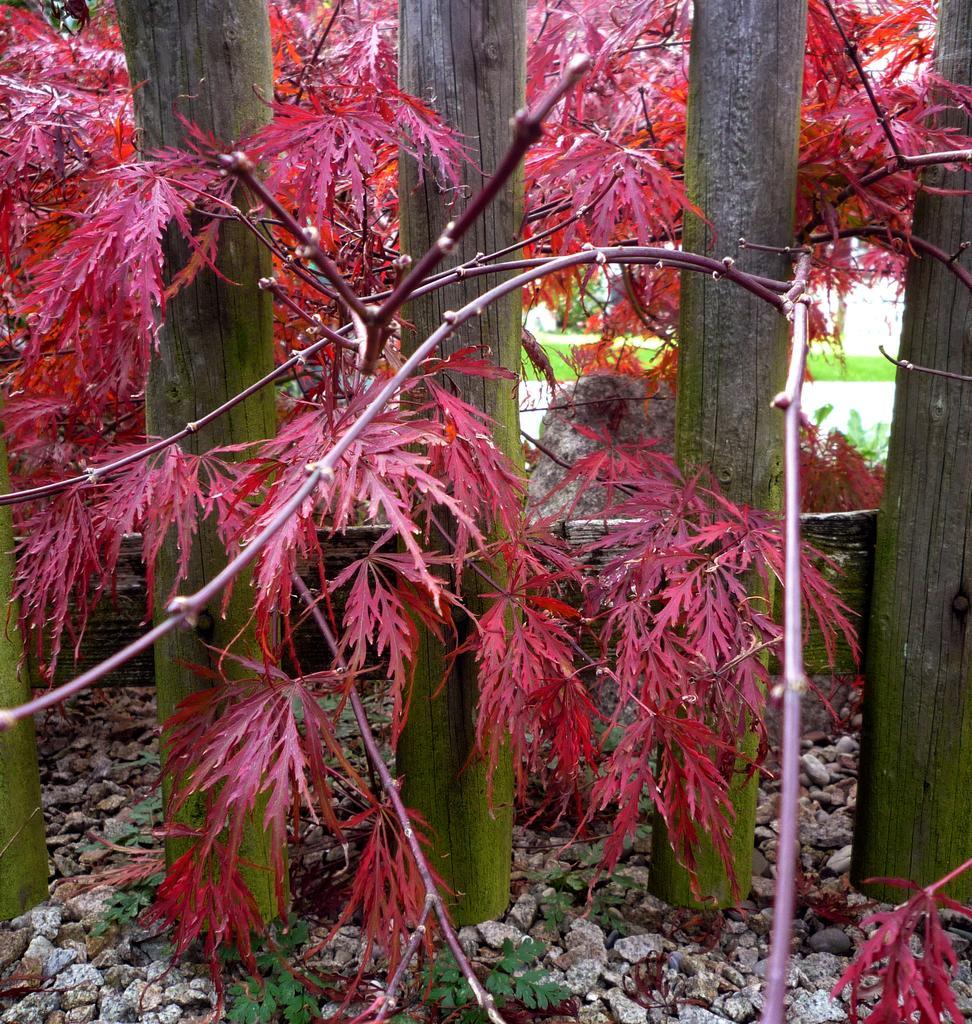In one or two sentences, can you explain what this image depicts? In this image there are trees, there are stones on the ground, there is a fence and in the background there is grass on the ground. 